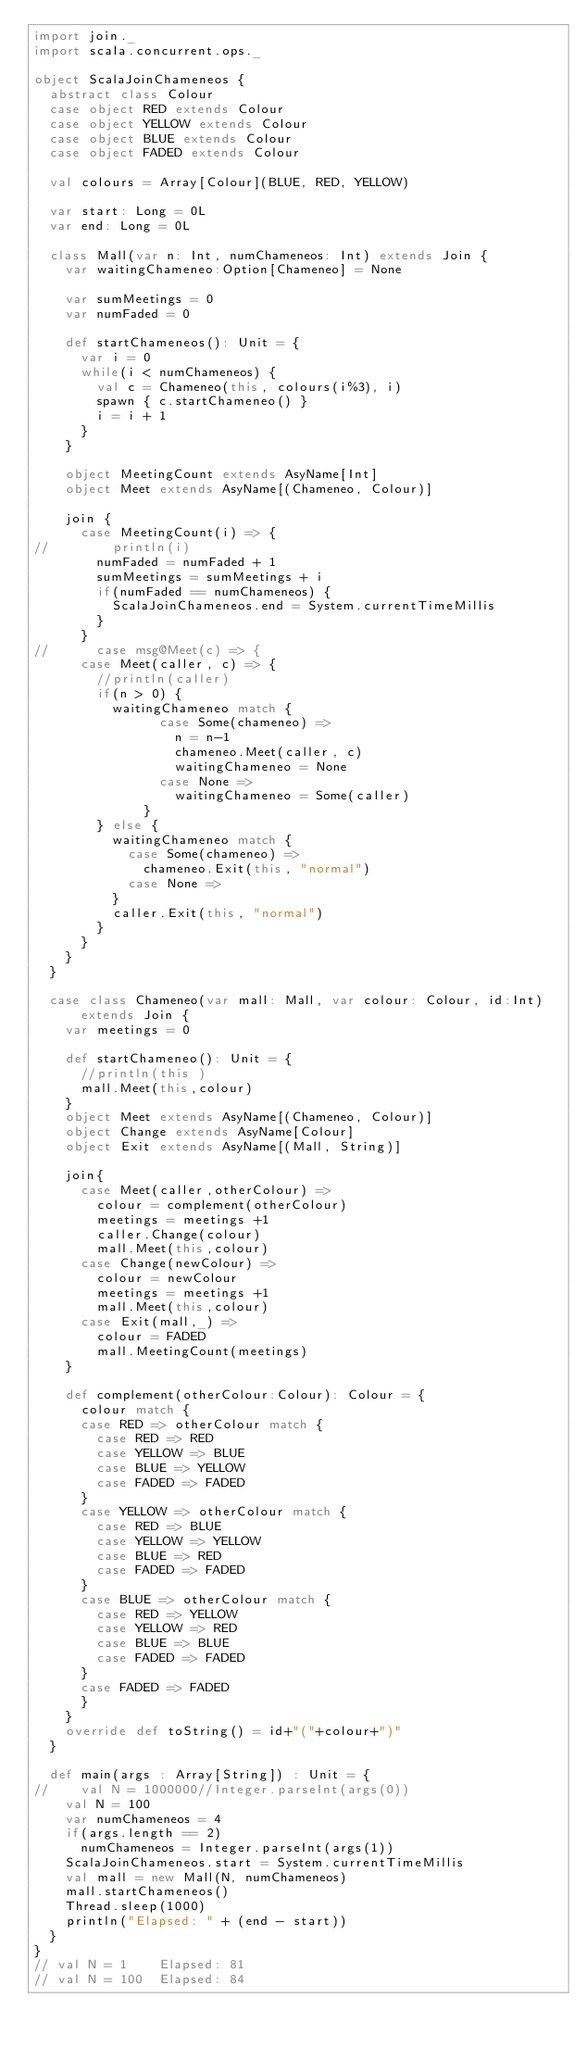<code> <loc_0><loc_0><loc_500><loc_500><_Scala_>import join._
import scala.concurrent.ops._

object ScalaJoinChameneos {
  abstract class Colour
  case object RED extends Colour
  case object YELLOW extends Colour
  case object BLUE extends Colour
  case object FADED extends Colour
  
  val colours = Array[Colour](BLUE, RED, YELLOW)
  
  var start: Long = 0L
  var end: Long = 0L
  
  class Mall(var n: Int, numChameneos: Int) extends Join {
    var waitingChameneo:Option[Chameneo] = None

    var sumMeetings = 0
    var numFaded = 0
    
    def startChameneos(): Unit = {
      var i = 0
      while(i < numChameneos) {
        val c = Chameneo(this, colours(i%3), i)
        spawn { c.startChameneo() }
        i = i + 1
      }
    }
    
    object MeetingCount extends AsyName[Int]
    object Meet extends AsyName[(Chameneo, Colour)]
    
    join {
      case MeetingCount(i) => {
//        println(i)
        numFaded = numFaded + 1
        sumMeetings = sumMeetings + i
        if(numFaded == numChameneos) {
          ScalaJoinChameneos.end = System.currentTimeMillis
        }
      }
//      case msg@Meet(c) => {
      case Meet(caller, c) => {
        //println(caller)
        if(n > 0) {
	      waitingChameneo match {
                case Some(chameneo) =>
                  n = n-1
                  chameneo.Meet(caller, c)
                  waitingChameneo = None
                case None =>
                  waitingChameneo = Some(caller)
              }
        } else {
          waitingChameneo match {
            case Some(chameneo) =>
              chameneo.Exit(this, "normal")
            case None => 
          }
          caller.Exit(this, "normal")
        }
      }
    }
  }
  
  case class Chameneo(var mall: Mall, var colour: Colour, id:Int) extends Join {
    var meetings = 0
    
    def startChameneo(): Unit = {
      //println(this )
      mall.Meet(this,colour)
    }
    object Meet extends AsyName[(Chameneo, Colour)]
    object Change extends AsyName[Colour]
    object Exit extends AsyName[(Mall, String)]
    
    join{
      case Meet(caller,otherColour) =>
        colour = complement(otherColour)
        meetings = meetings +1
        caller.Change(colour)
        mall.Meet(this,colour)
      case Change(newColour) =>
        colour = newColour
        meetings = meetings +1
        mall.Meet(this,colour)
      case Exit(mall,_) =>
	    colour = FADED
        mall.MeetingCount(meetings)
    }
    
    def complement(otherColour:Colour): Colour = {
      colour match {
      case RED => otherColour match {
        case RED => RED
        case YELLOW => BLUE
        case BLUE => YELLOW
        case FADED => FADED
      }
      case YELLOW => otherColour match {
        case RED => BLUE
        case YELLOW => YELLOW
        case BLUE => RED
        case FADED => FADED
      }
      case BLUE => otherColour match {
        case RED => YELLOW
        case YELLOW => RED
        case BLUE => BLUE
        case FADED => FADED
      }
      case FADED => FADED
      }
    }
    override def toString() = id+"("+colour+")"
  }
  
  def main(args : Array[String]) : Unit = {
//    val N = 1000000//Integer.parseInt(args(0))
    val N = 100
    var numChameneos = 4
    if(args.length == 2)
      numChameneos = Integer.parseInt(args(1))
    ScalaJoinChameneos.start = System.currentTimeMillis
    val mall = new Mall(N, numChameneos)
    mall.startChameneos()
    Thread.sleep(1000)
    println("Elapsed: " + (end - start))
  }
}
// val N = 1    Elapsed: 81
// val N = 100  Elapsed: 84</code> 